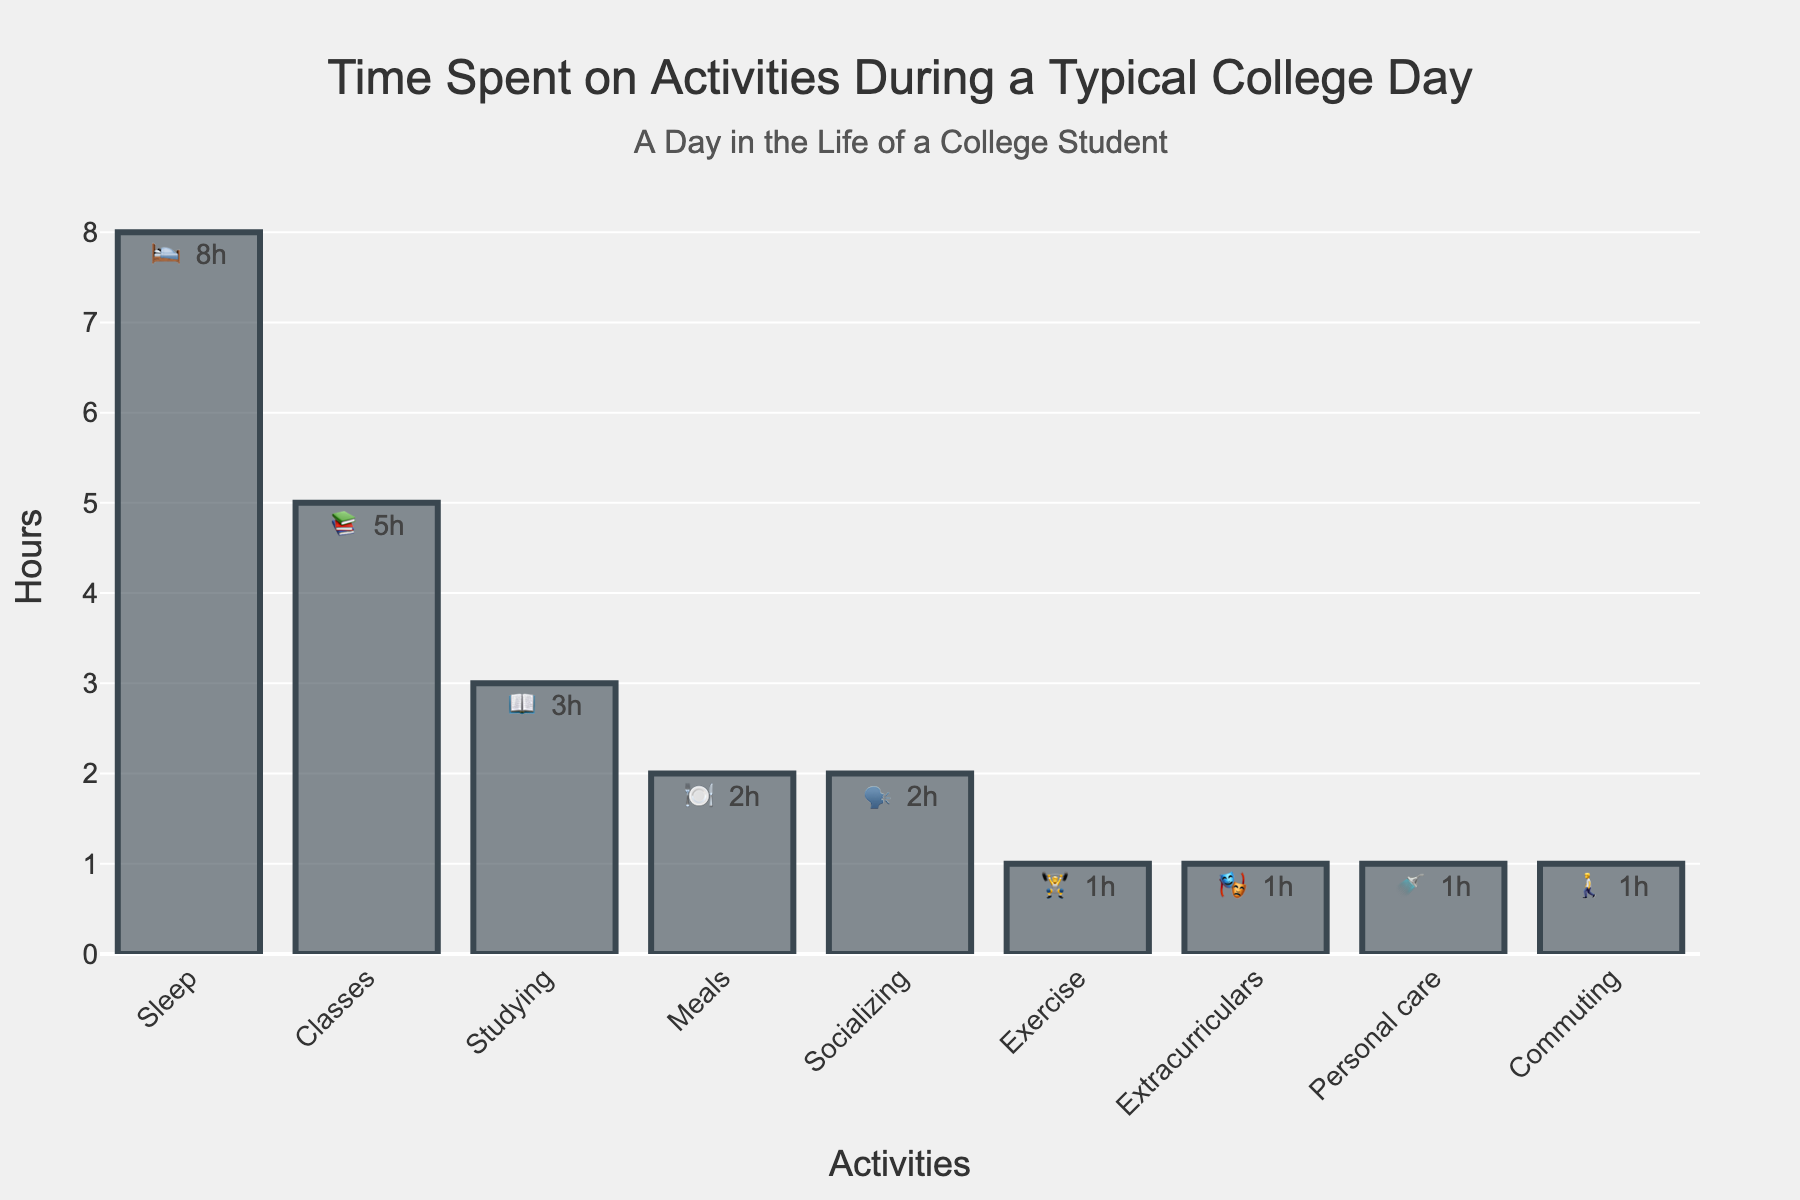What is the title of the chart? The title is usually at the top of the chart. Here, it reads: "Time Spent on Activities During a Typical College Day".
Answer: Time Spent on Activities During a Typical College Day How many hours are spent sleeping? Look for the bar labeled with the emoji 🛌 and the text next to it. It shows "8h".
Answer: 8 hours Which activity takes the least amount of time? Identify the smallest bar in the chart. Both Exercise 🏋️, Extracurriculars 🎭, Personal care 🚿, and Commuting 🚶 all have the smallest bars showing 1 hour each.
Answer: Exercise, Extracurriculars, Personal care, Commuting How many activities take up exactly 2 hours each? Count the number of bars with the text "2h" next to them. They are Meals 🍽️ and Socializing 🗣️.
Answer: 2 activities How many total hours are spent on studying and classes combined? Add the hours for Studying 📖 (3h) and Classes 📚 (5h). 3 + 5 = 8 hours.
Answer: 8 hours Which activity takes more time: Socializing or Exercise? Compare the bars for Socializing 🗣️ and Exercise 🏋️. Socializing is 2 hours, and Exercise is 1 hour.
Answer: Socializing What is the average amount of time spent on Meals, Socializing, and Personal care? Calculate the average by summing the hours (2h for Meals, 2h for Socializing, 1h for Personal care) and divide by 3. (2 + 2 + 1) / 3 = 1.67 hours.
Answer: 1.67 hours Which activities take the same amount of time? Identify bars with the same height and accompanying text showing the same number of hours. Meals 🍽️ and Socializing 🗣️ both take 2 hours. Exercise 🏋️, Extracurriculars 🎭, Personal care 🚿, and Commuting 🚶 all take 1 hour each.
Answer: Meals and Socializing; Exercise, Extracurriculars, Personal care, and Commuting How many hours are spent on non-academic activities (excluding Sleep)? Sum the hours of all activities except Sleep 🛌 and academic activities (Classes 📚 and Studying 📖). Meals 🍽️ (2h) + Socializing 🗣️ (2h) + Exercise 🏋️ (1h) + Extracurriculars 🎭 (1h) + Personal care 🚿 (1h) + Commuting 🚶 (1h). 2 + 2 + 1 + 1 + 1 + 1 = 8 hours.
Answer: 8 hours 